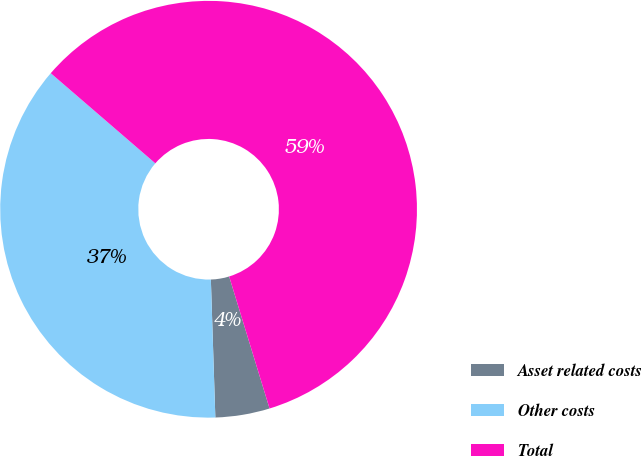<chart> <loc_0><loc_0><loc_500><loc_500><pie_chart><fcel>Asset related costs<fcel>Other costs<fcel>Total<nl><fcel>4.21%<fcel>36.84%<fcel>58.95%<nl></chart> 